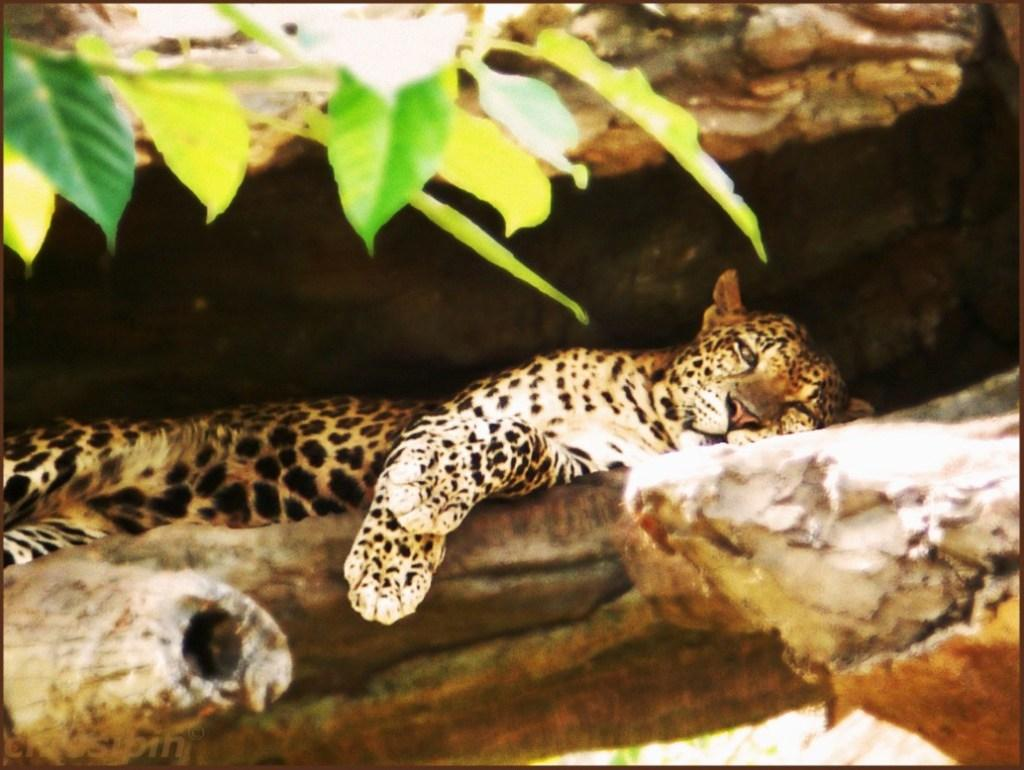What type of animal is in the image? There is a Cheetah in the image. What is the Cheetah resting on? The Cheetah is laying on a wooden surface. What can be seen at the top of the image? There are leaves on a stem visible at the top of the image. What type of wire is holding up the scarecrow in the image? There is no scarecrow or wire present in the image; it features a Cheetah laying on a wooden surface with leaves on a stem visible at the top. 